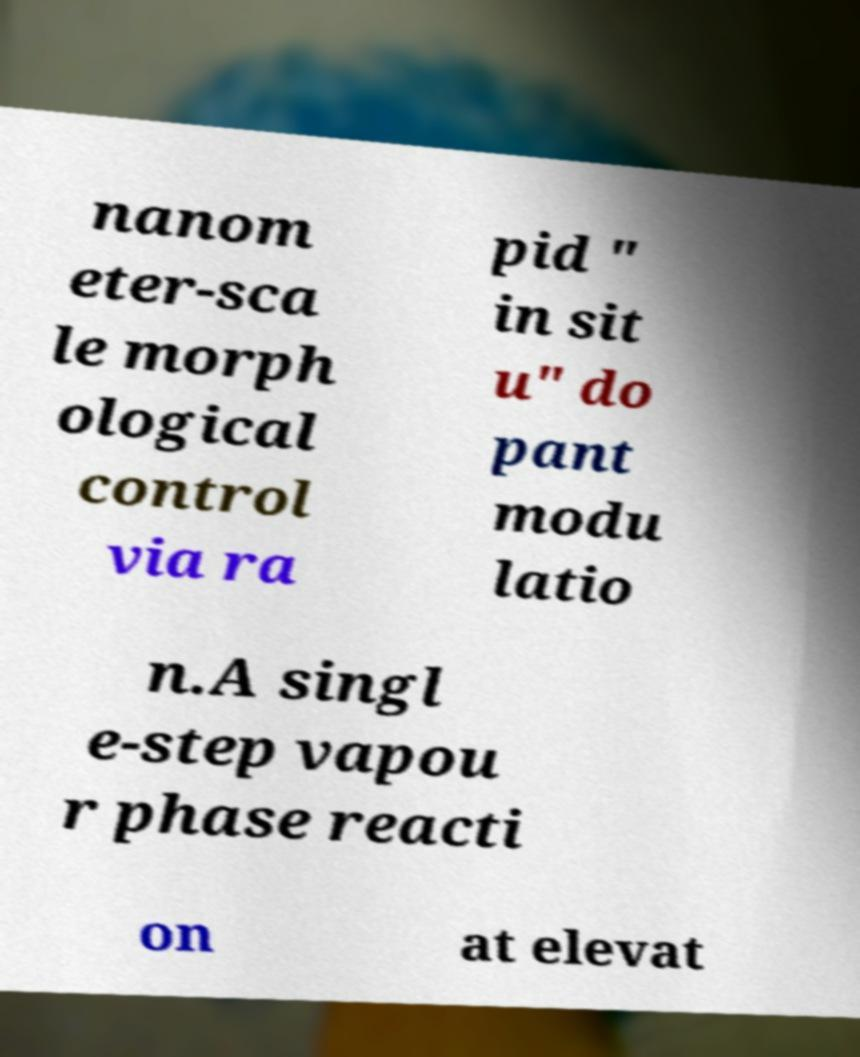For documentation purposes, I need the text within this image transcribed. Could you provide that? nanom eter-sca le morph ological control via ra pid " in sit u" do pant modu latio n.A singl e-step vapou r phase reacti on at elevat 